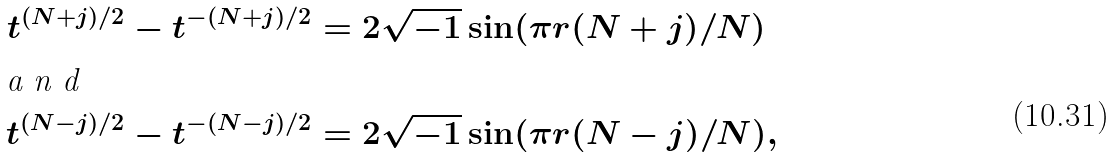Convert formula to latex. <formula><loc_0><loc_0><loc_500><loc_500>t ^ { ( N + j ) / 2 } - t ^ { - ( N + j ) / 2 } & = 2 \sqrt { - 1 } \sin ( \pi r ( N + j ) / N ) \\ \intertext { a n d } t ^ { ( N - j ) / 2 } - t ^ { - ( N - j ) / 2 } & = 2 \sqrt { - 1 } \sin ( \pi r ( N - j ) / N ) ,</formula> 